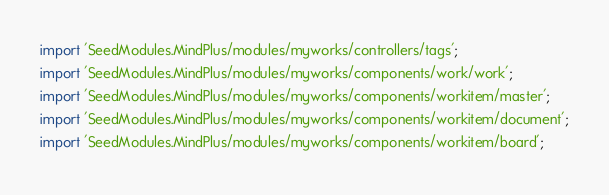<code> <loc_0><loc_0><loc_500><loc_500><_TypeScript_>import 'SeedModules.MindPlus/modules/myworks/controllers/tags';
import 'SeedModules.MindPlus/modules/myworks/components/work/work';
import 'SeedModules.MindPlus/modules/myworks/components/workitem/master';
import 'SeedModules.MindPlus/modules/myworks/components/workitem/document';
import 'SeedModules.MindPlus/modules/myworks/components/workitem/board';
</code> 